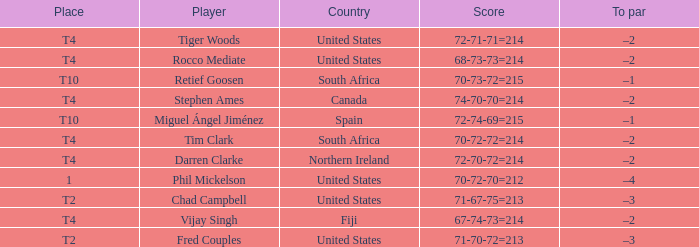What place was the scorer of 67-74-73=214? T4. 